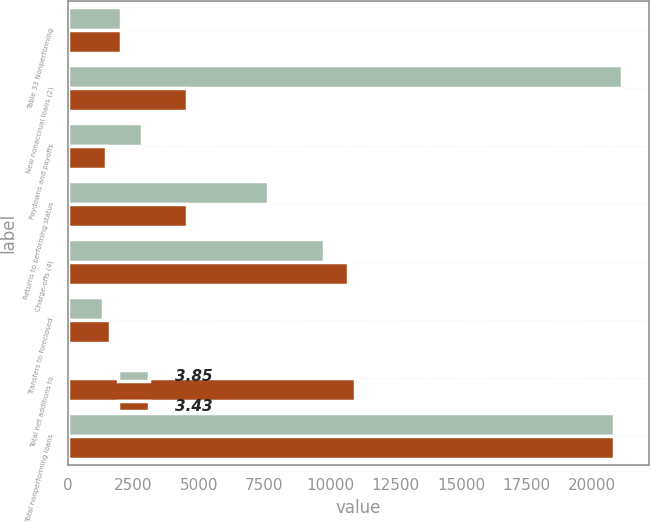<chart> <loc_0><loc_0><loc_500><loc_500><stacked_bar_chart><ecel><fcel>Table 33 Nonperforming<fcel>New nonaccrual loans (2)<fcel>Paydowns and payoffs<fcel>Returns to performing status<fcel>Charge-offs (4)<fcel>Transfers to foreclosed<fcel>Total net additions to<fcel>Total nonperforming loans<nl><fcel>3.85<fcel>2010<fcel>21136<fcel>2809<fcel>7647<fcel>9772<fcel>1341<fcel>15<fcel>20854<nl><fcel>3.43<fcel>2009<fcel>4540<fcel>1459<fcel>4540<fcel>10702<fcel>1619<fcel>10951<fcel>20839<nl></chart> 